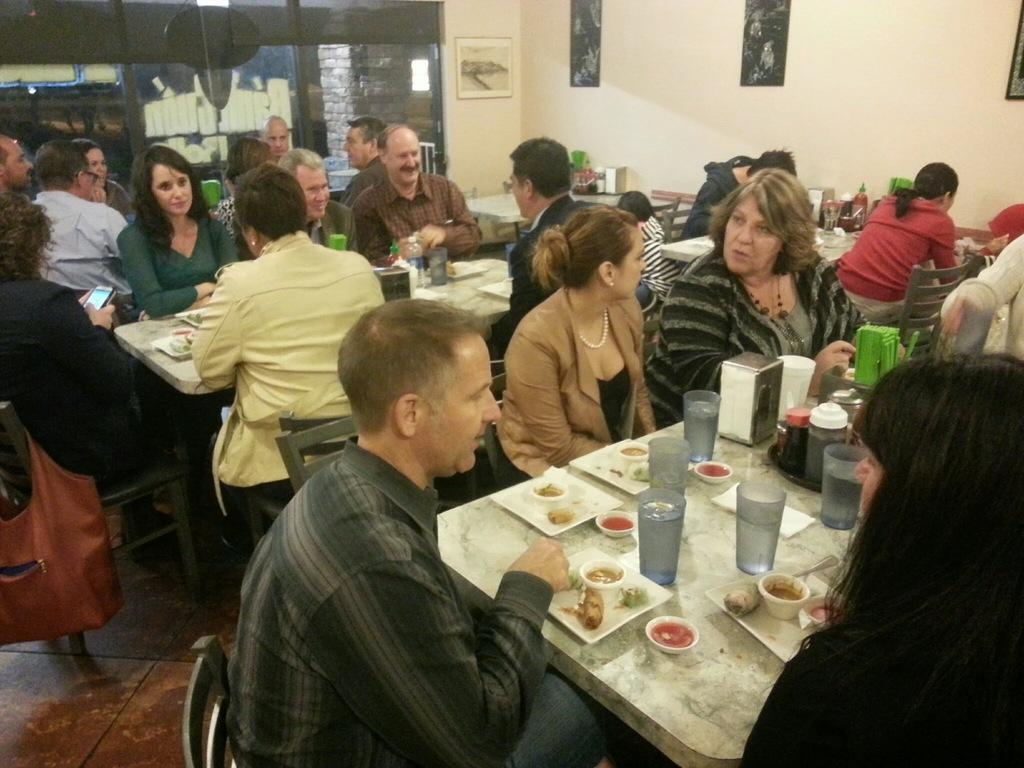What are the people in the image doing? The people in the image are sitting on chairs. What can be found on the tables in the image? There are glasses, plates, food, bowls, and a ketchup bottle on the tables. What is visible on the wall in the background? There are frames on the wall. What is the setting of the scene in the image? The scene is on a floor. How many kites are being flown by the people in the image? There are no kites visible in the image; the people are sitting on chairs and there are objects on the tables. What type of soda is being served in the glasses on the tables? There is no mention of soda in the image; only glasses, plates, food, bowls, and a ketchup bottle are visible on the tables. 